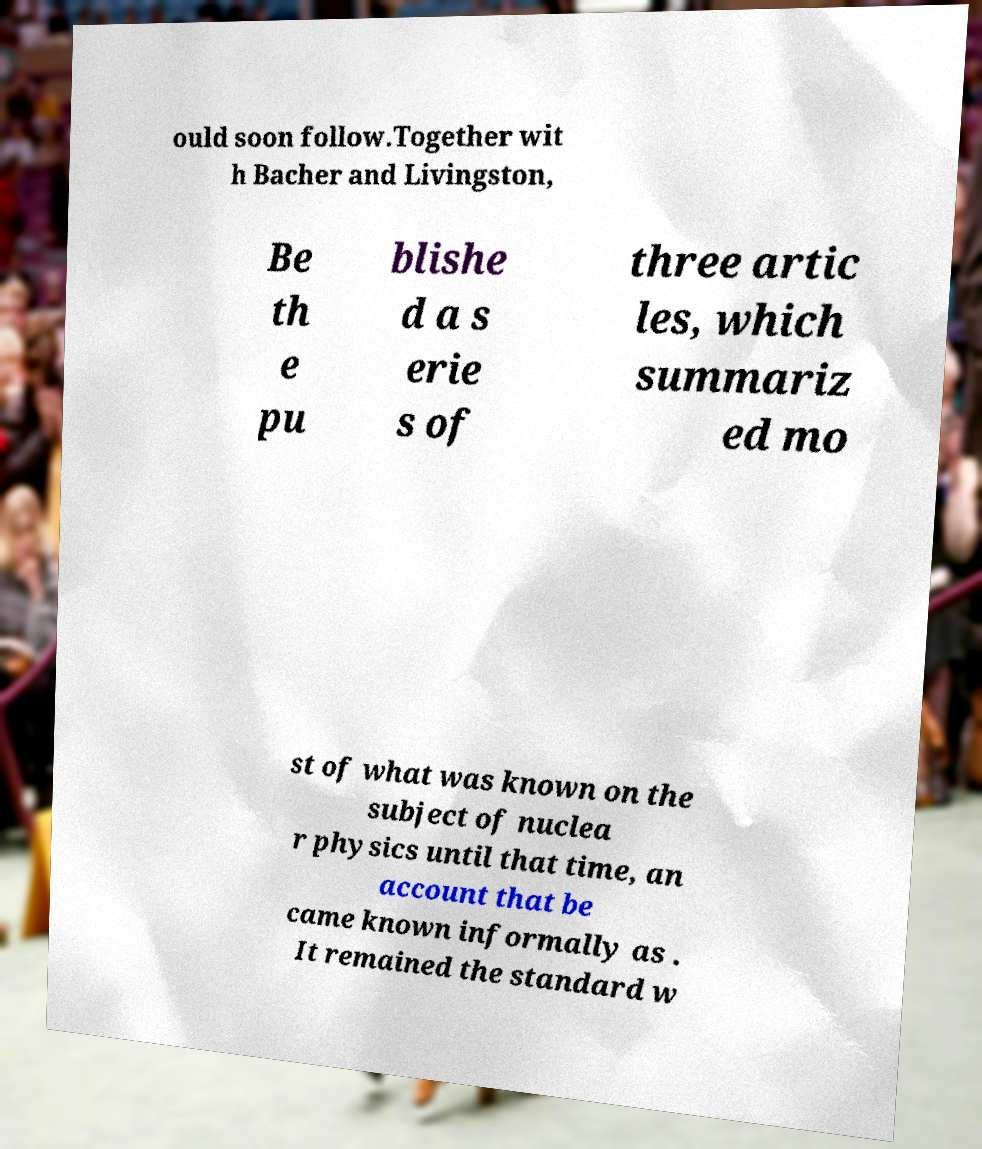Could you assist in decoding the text presented in this image and type it out clearly? ould soon follow.Together wit h Bacher and Livingston, Be th e pu blishe d a s erie s of three artic les, which summariz ed mo st of what was known on the subject of nuclea r physics until that time, an account that be came known informally as . It remained the standard w 